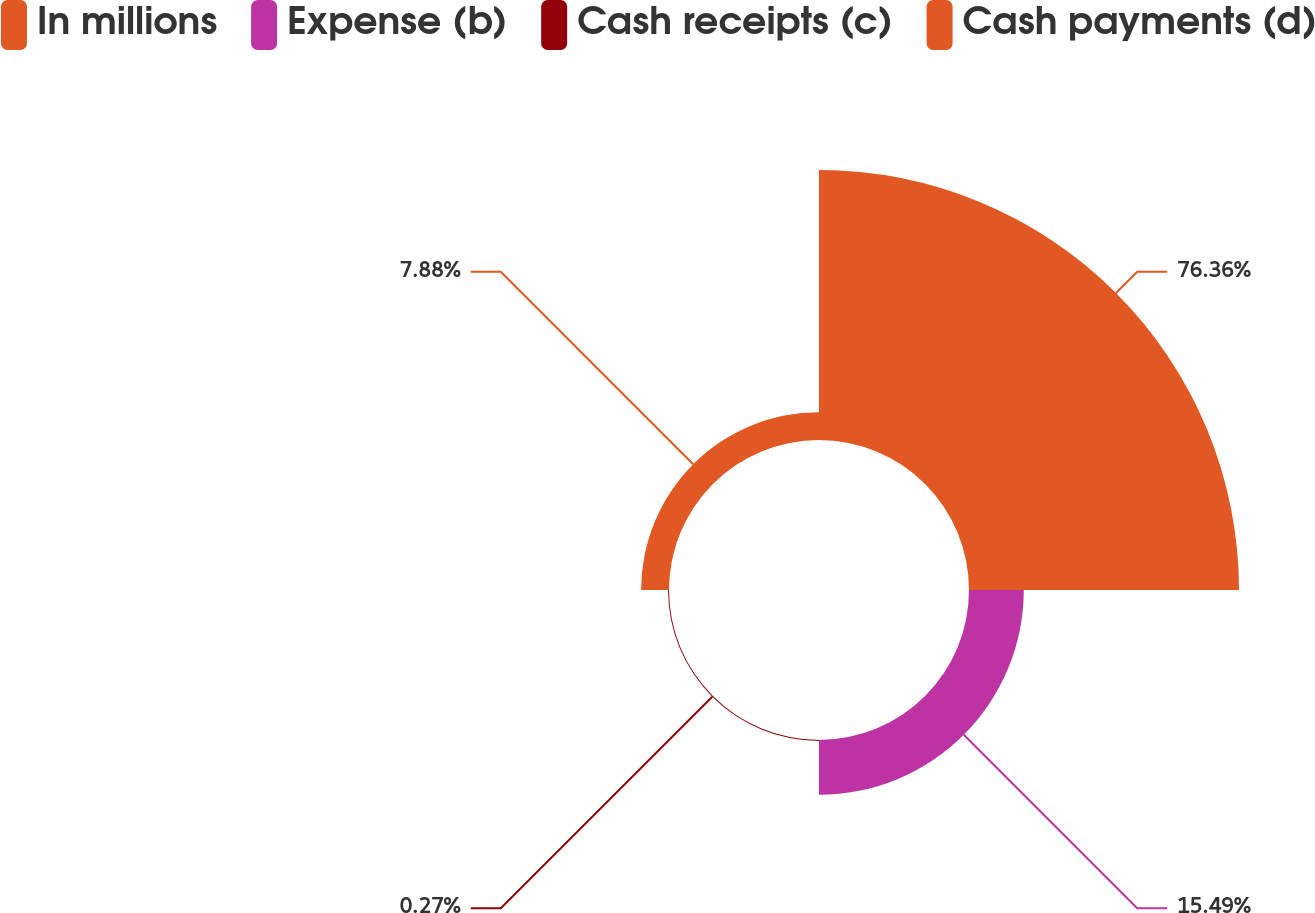Convert chart. <chart><loc_0><loc_0><loc_500><loc_500><pie_chart><fcel>In millions<fcel>Expense (b)<fcel>Cash receipts (c)<fcel>Cash payments (d)<nl><fcel>76.37%<fcel>15.49%<fcel>0.27%<fcel>7.88%<nl></chart> 